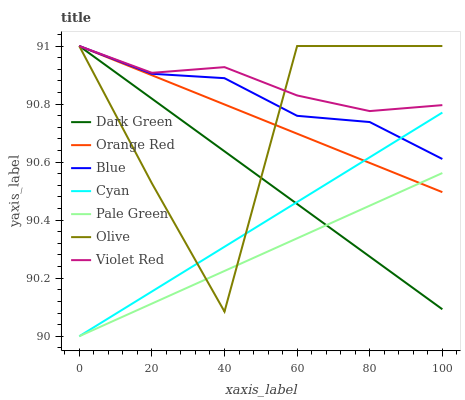Does Violet Red have the minimum area under the curve?
Answer yes or no. No. Does Pale Green have the maximum area under the curve?
Answer yes or no. No. Is Violet Red the smoothest?
Answer yes or no. No. Is Violet Red the roughest?
Answer yes or no. No. Does Violet Red have the lowest value?
Answer yes or no. No. Does Pale Green have the highest value?
Answer yes or no. No. Is Pale Green less than Violet Red?
Answer yes or no. Yes. Is Violet Red greater than Cyan?
Answer yes or no. Yes. Does Pale Green intersect Violet Red?
Answer yes or no. No. 